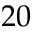Convert formula to latex. <formula><loc_0><loc_0><loc_500><loc_500>2 0</formula> 